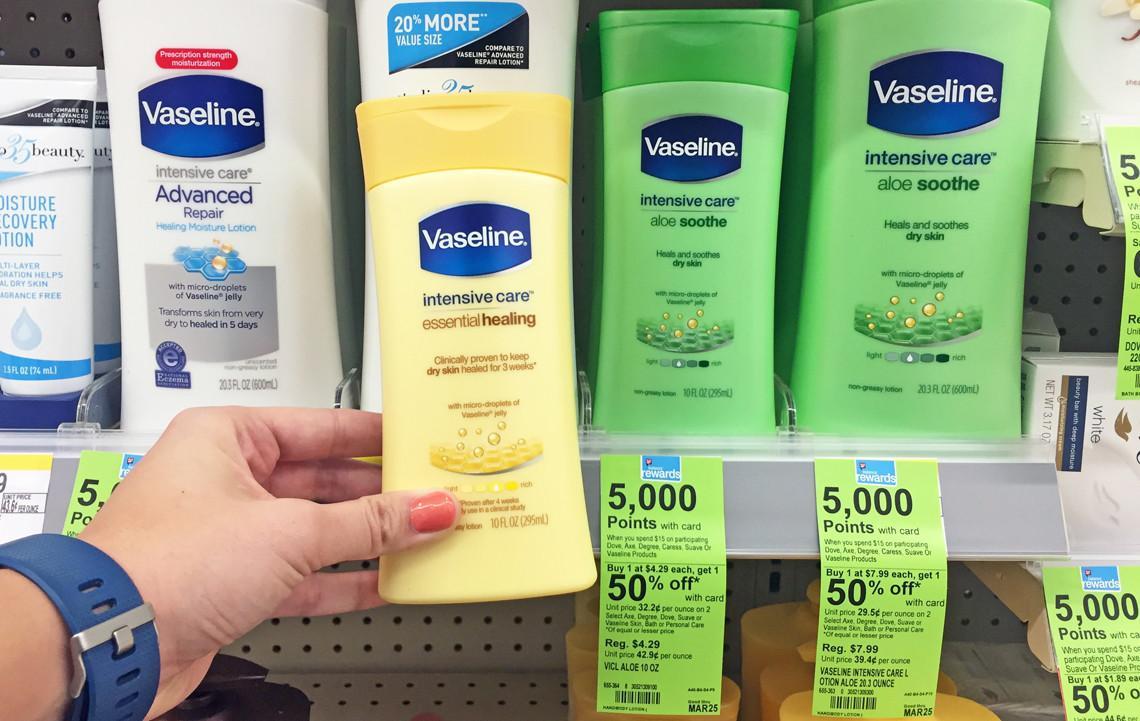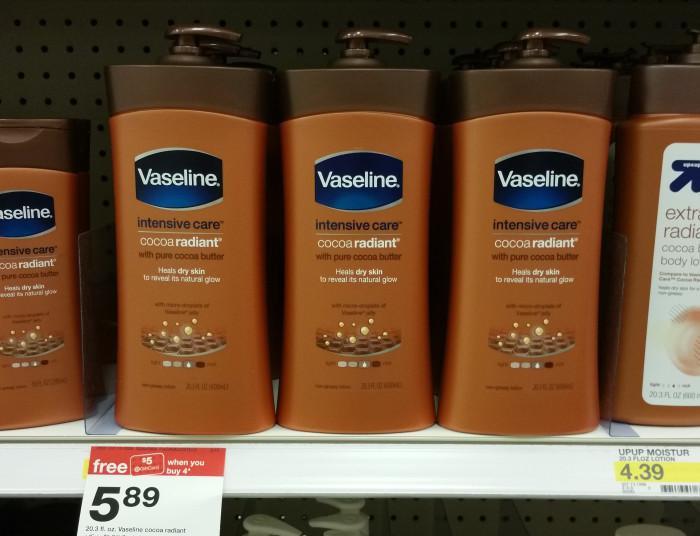The first image is the image on the left, the second image is the image on the right. Evaluate the accuracy of this statement regarding the images: "There is a hand holding product next to the shelf that shows the sales prices, on the wrist is a watch". Is it true? Answer yes or no. Yes. The first image is the image on the left, the second image is the image on the right. Assess this claim about the two images: "Some price tags are green.". Correct or not? Answer yes or no. Yes. 